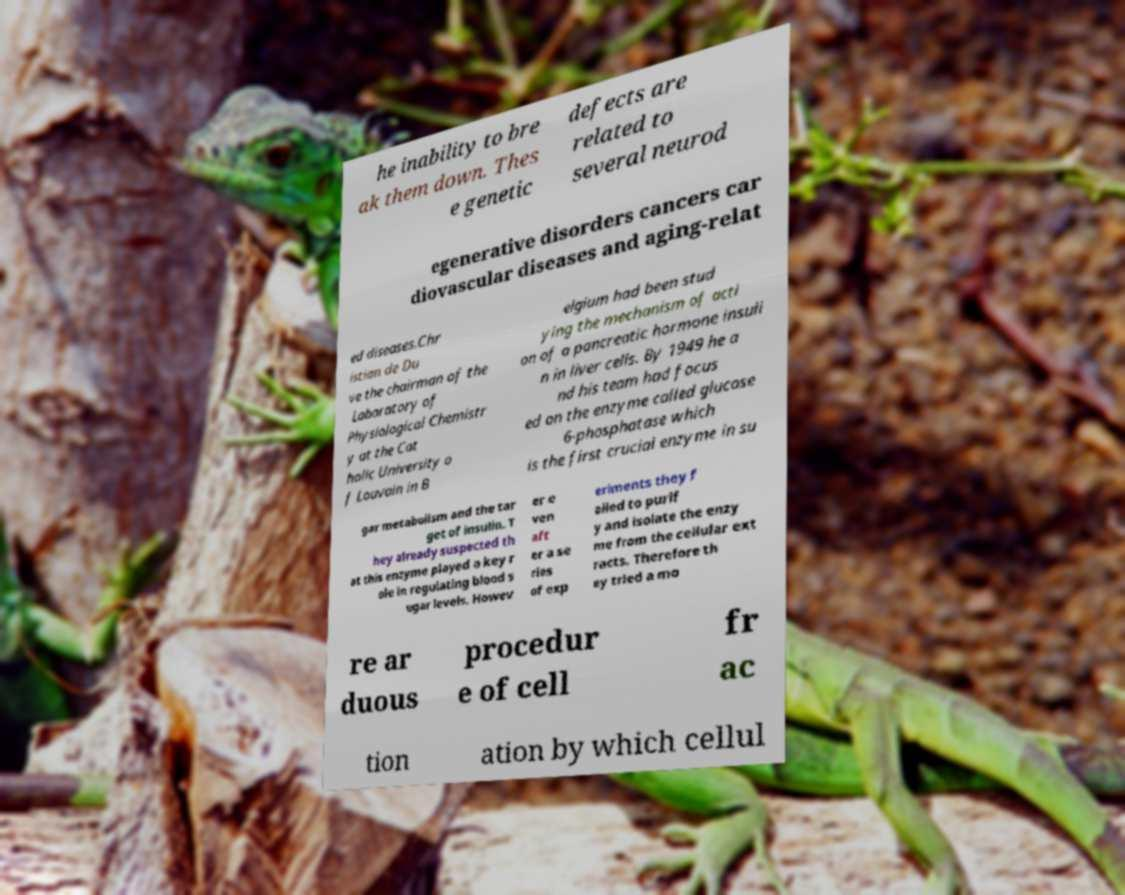What messages or text are displayed in this image? I need them in a readable, typed format. he inability to bre ak them down. Thes e genetic defects are related to several neurod egenerative disorders cancers car diovascular diseases and aging-relat ed diseases.Chr istian de Du ve the chairman of the Laboratory of Physiological Chemistr y at the Cat holic University o f Louvain in B elgium had been stud ying the mechanism of acti on of a pancreatic hormone insuli n in liver cells. By 1949 he a nd his team had focus ed on the enzyme called glucose 6-phosphatase which is the first crucial enzyme in su gar metabolism and the tar get of insulin. T hey already suspected th at this enzyme played a key r ole in regulating blood s ugar levels. Howev er e ven aft er a se ries of exp eriments they f ailed to purif y and isolate the enzy me from the cellular ext racts. Therefore th ey tried a mo re ar duous procedur e of cell fr ac tion ation by which cellul 